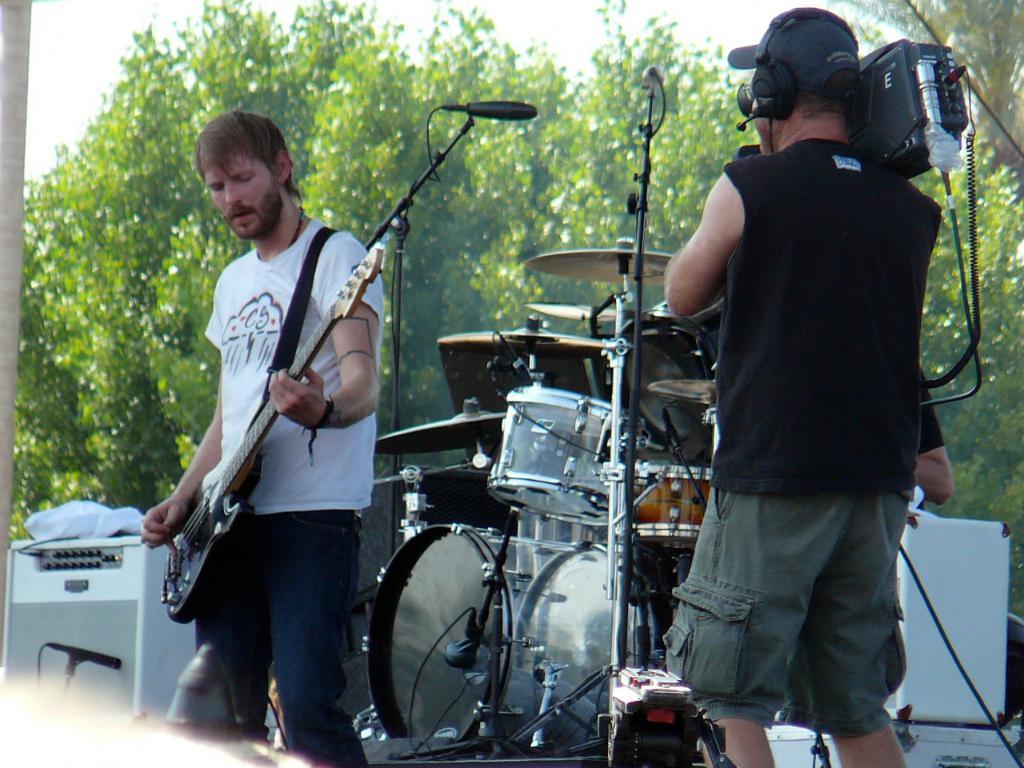Please provide a concise description of this image. In the middle of the image a man is standing and playing guitar. Bottom right side of the image a man is standing and holding something in his hands. In the middle of the image there is a drum. Behind the drum there are some trees. Top left side of the image there is sky. Bottom left side of the image there are some electronic devices. 